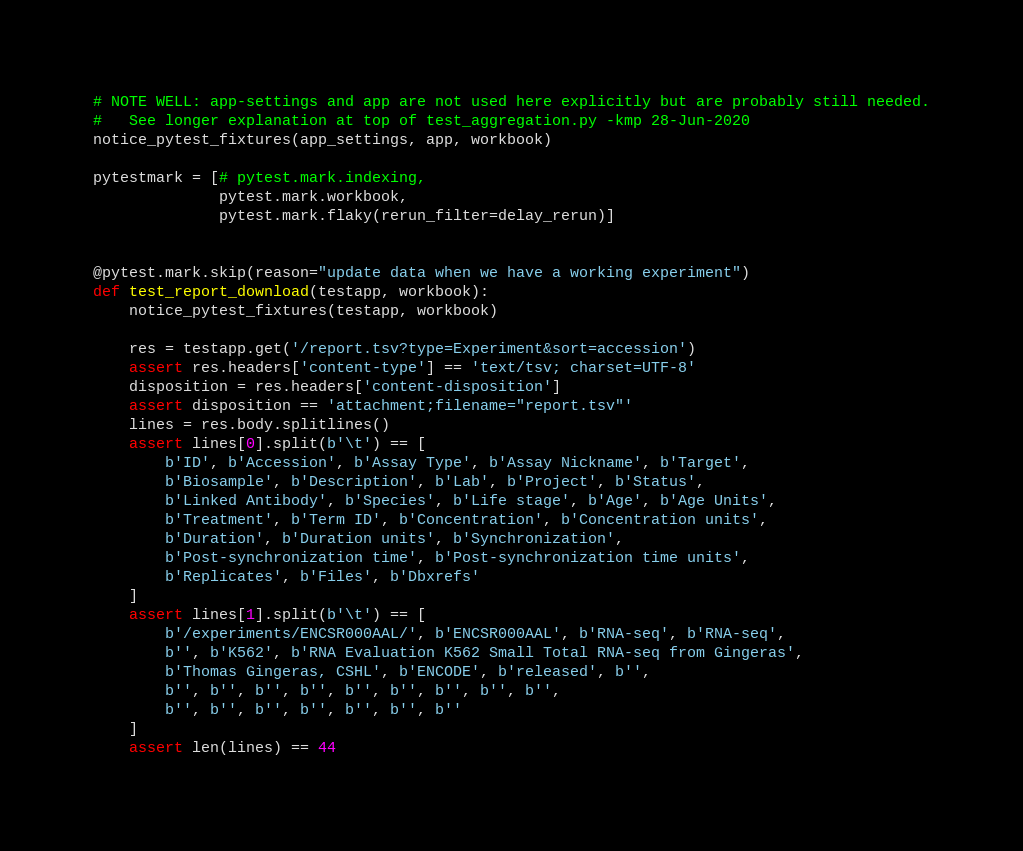<code> <loc_0><loc_0><loc_500><loc_500><_Python_>

# NOTE WELL: app-settings and app are not used here explicitly but are probably still needed.
#   See longer explanation at top of test_aggregation.py -kmp 28-Jun-2020
notice_pytest_fixtures(app_settings, app, workbook)

pytestmark = [# pytest.mark.indexing,
              pytest.mark.workbook,
              pytest.mark.flaky(rerun_filter=delay_rerun)]


@pytest.mark.skip(reason="update data when we have a working experiment")
def test_report_download(testapp, workbook):
    notice_pytest_fixtures(testapp, workbook)

    res = testapp.get('/report.tsv?type=Experiment&sort=accession')
    assert res.headers['content-type'] == 'text/tsv; charset=UTF-8'
    disposition = res.headers['content-disposition']
    assert disposition == 'attachment;filename="report.tsv"'
    lines = res.body.splitlines()
    assert lines[0].split(b'\t') == [
        b'ID', b'Accession', b'Assay Type', b'Assay Nickname', b'Target',
        b'Biosample', b'Description', b'Lab', b'Project', b'Status',
        b'Linked Antibody', b'Species', b'Life stage', b'Age', b'Age Units',
        b'Treatment', b'Term ID', b'Concentration', b'Concentration units',
        b'Duration', b'Duration units', b'Synchronization',
        b'Post-synchronization time', b'Post-synchronization time units',
        b'Replicates', b'Files', b'Dbxrefs'
    ]
    assert lines[1].split(b'\t') == [
        b'/experiments/ENCSR000AAL/', b'ENCSR000AAL', b'RNA-seq', b'RNA-seq',
        b'', b'K562', b'RNA Evaluation K562 Small Total RNA-seq from Gingeras',
        b'Thomas Gingeras, CSHL', b'ENCODE', b'released', b'',
        b'', b'', b'', b'', b'', b'', b'', b'', b'',
        b'', b'', b'', b'', b'', b'', b''
    ]
    assert len(lines) == 44
</code> 